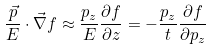<formula> <loc_0><loc_0><loc_500><loc_500>\frac { \vec { p } } { E } \cdot \vec { \nabla } f \approx \frac { p _ { z } } { E } \frac { \partial f } { \partial z } = - \frac { p _ { z } } { t } \frac { \partial f } { \partial p _ { z } }</formula> 